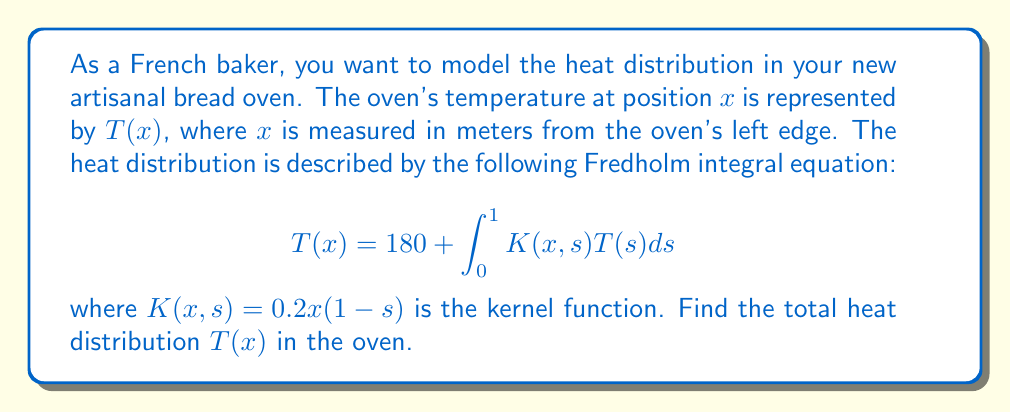Provide a solution to this math problem. To solve this Fredholm integral equation, we'll use the method of successive approximations:

1) Start with the initial approximation $T_0(x) = 180$.

2) Substitute this into the integral equation to get the next approximation:

   $$T_1(x) = 180 + \int_0^1 0.2x(1-s)180ds$$

3) Evaluate the integral:
   
   $$T_1(x) = 180 + 180 \cdot 0.2x \int_0^1 (1-s)ds = 180 + 180 \cdot 0.2x \cdot 0.5 = 180 + 18x$$

4) For the next iteration, use $T_1(x)$ in the integral:

   $$T_2(x) = 180 + \int_0^1 0.2x(1-s)(180+18s)ds$$

5) Evaluate this integral:

   $$T_2(x) = 180 + 0.2x[180\int_0^1 (1-s)ds + 18\int_0^1 (s-s^2)ds]$$
   $$= 180 + 0.2x[180 \cdot 0.5 + 18 \cdot (\frac{1}{2} - \frac{1}{3})]$$
   $$= 180 + 18x + 0.6x$$

6) The process converges quickly. The difference between $T_2(x)$ and $T_1(x)$ is small (0.6x), so we can stop here.

Therefore, the approximate solution is:

$$T(x) \approx 180 + 18.6x$$
Answer: $T(x) \approx 180 + 18.6x$ 